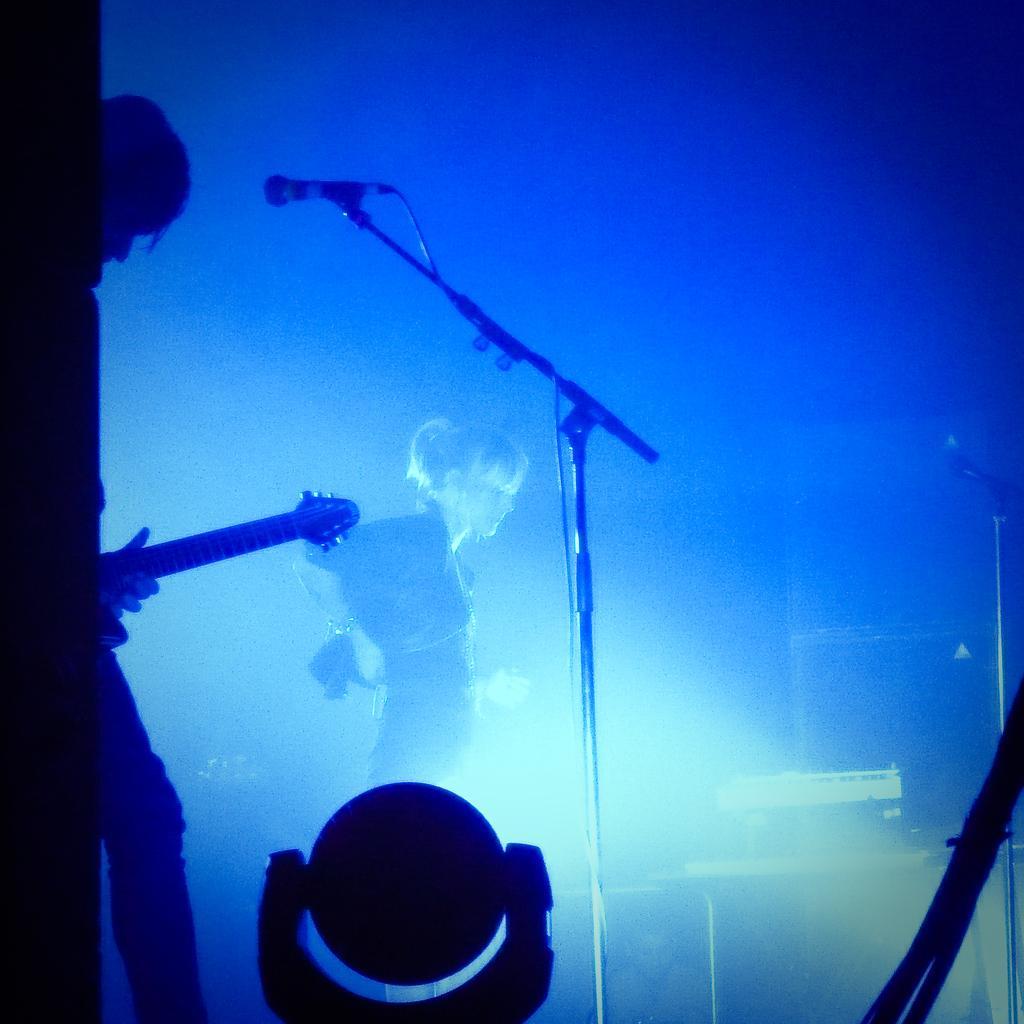Can you describe this image briefly? In the foreground of this picture, there is a man holding a guitar and a woman standing in the background. There is a mic in front of a man. On the bottom, there is a light. 